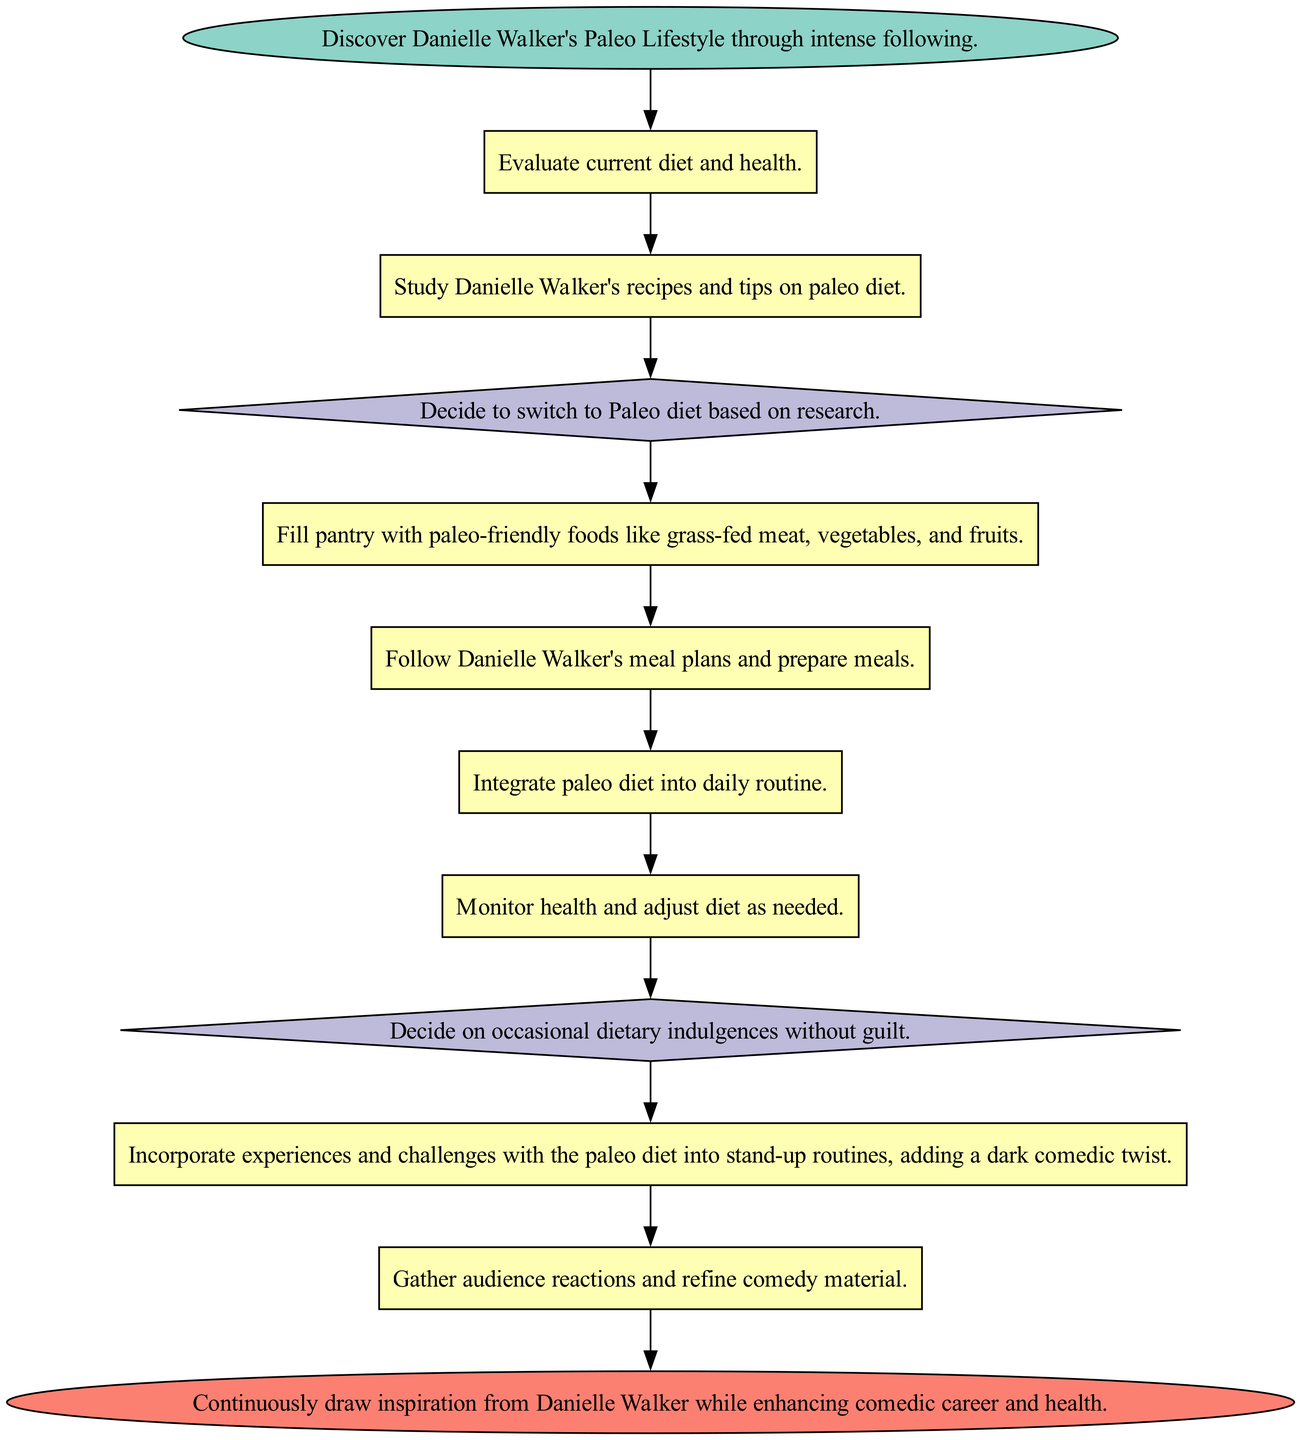What is the starting point of the dietary evolution? The starting point is labeled as "Motivation," which reflects the initial discovery of Danielle Walker's Paleo Lifestyle through intense following.
Answer: Motivation How many processes are in the dietary evolution? By counting the elements labeled as "process" in the diagram, including "Initial Assessment," "Research," "Stock Up," "Meal Prep," "Implementation," "Regular Check-In," "Comedic Spin," and "Audience Feedback," we find there are 7 such elements.
Answer: 7 What decision node follows "Research"? The decision node that follows "Research" is labeled "Dietary Transition," where the individual decides to switch to the Paleo diet based on their research findings.
Answer: Dietary Transition What types of elements exist in the diagram? The diagram contains four types of elements: "start," "process," "decision," and "end." These represent different stages or actions in the overall flow of the dietary evolution.
Answer: start, process, decision, end What happens after the "Cheat Days" decision? After the "Cheat Days" decision, the flow leads to the "Comedic Spin" process, indicating that experiences related to cheat days can be incorporated into comedy routines.
Answer: Comedic Spin What is the end point of the dietary evolution process? The end point of the dietary evolution process is labeled as "Inspiration Cycle," indicating a continuous loop of drawing inspiration from Danielle Walker while enhancing both the comedic career and health.
Answer: Inspiration Cycle How is "Regular Check-In" connected to the flow? "Regular Check-In" is a process that monitors health and adjusts the diet as needed, occurring before the "Cheat Days" decision and indicating consistency in adapting the diet.
Answer: Before "Cheat Days" What is the main purpose of "Comedic Spin"? The main purpose of "Comedic Spin" is to incorporate experiences and challenges related to the paleo diet into stand-up routines, specifically adding a dark comedic twist to the material.
Answer: Incorporate experiences into stand-up routines 